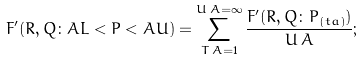<formula> <loc_0><loc_0><loc_500><loc_500>F ^ { \prime } ( R , Q \colon A L < P < A U ) = \sum _ { T \, A = 1 } ^ { U \, A = \infty } { \frac { F ^ { \prime } ( R , Q \colon P _ { ( t a ) } ) } { U \, A } } ; \,</formula> 